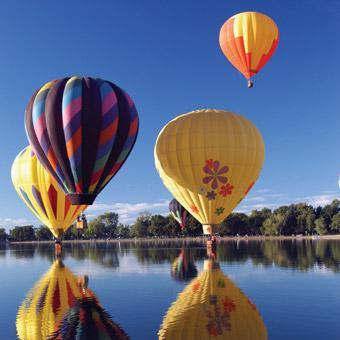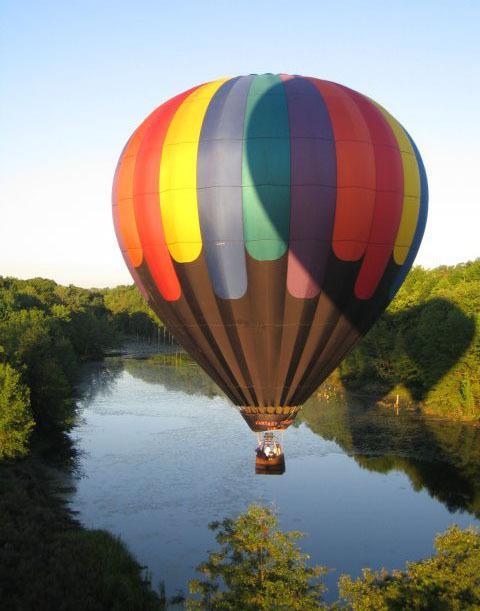The first image is the image on the left, the second image is the image on the right. For the images displayed, is the sentence "There are at least four balloons in the image on the left." factually correct? Answer yes or no. Yes. The first image is the image on the left, the second image is the image on the right. Given the left and right images, does the statement "In one image, a face is designed on the side of a large yellow hot-air balloon." hold true? Answer yes or no. No. 